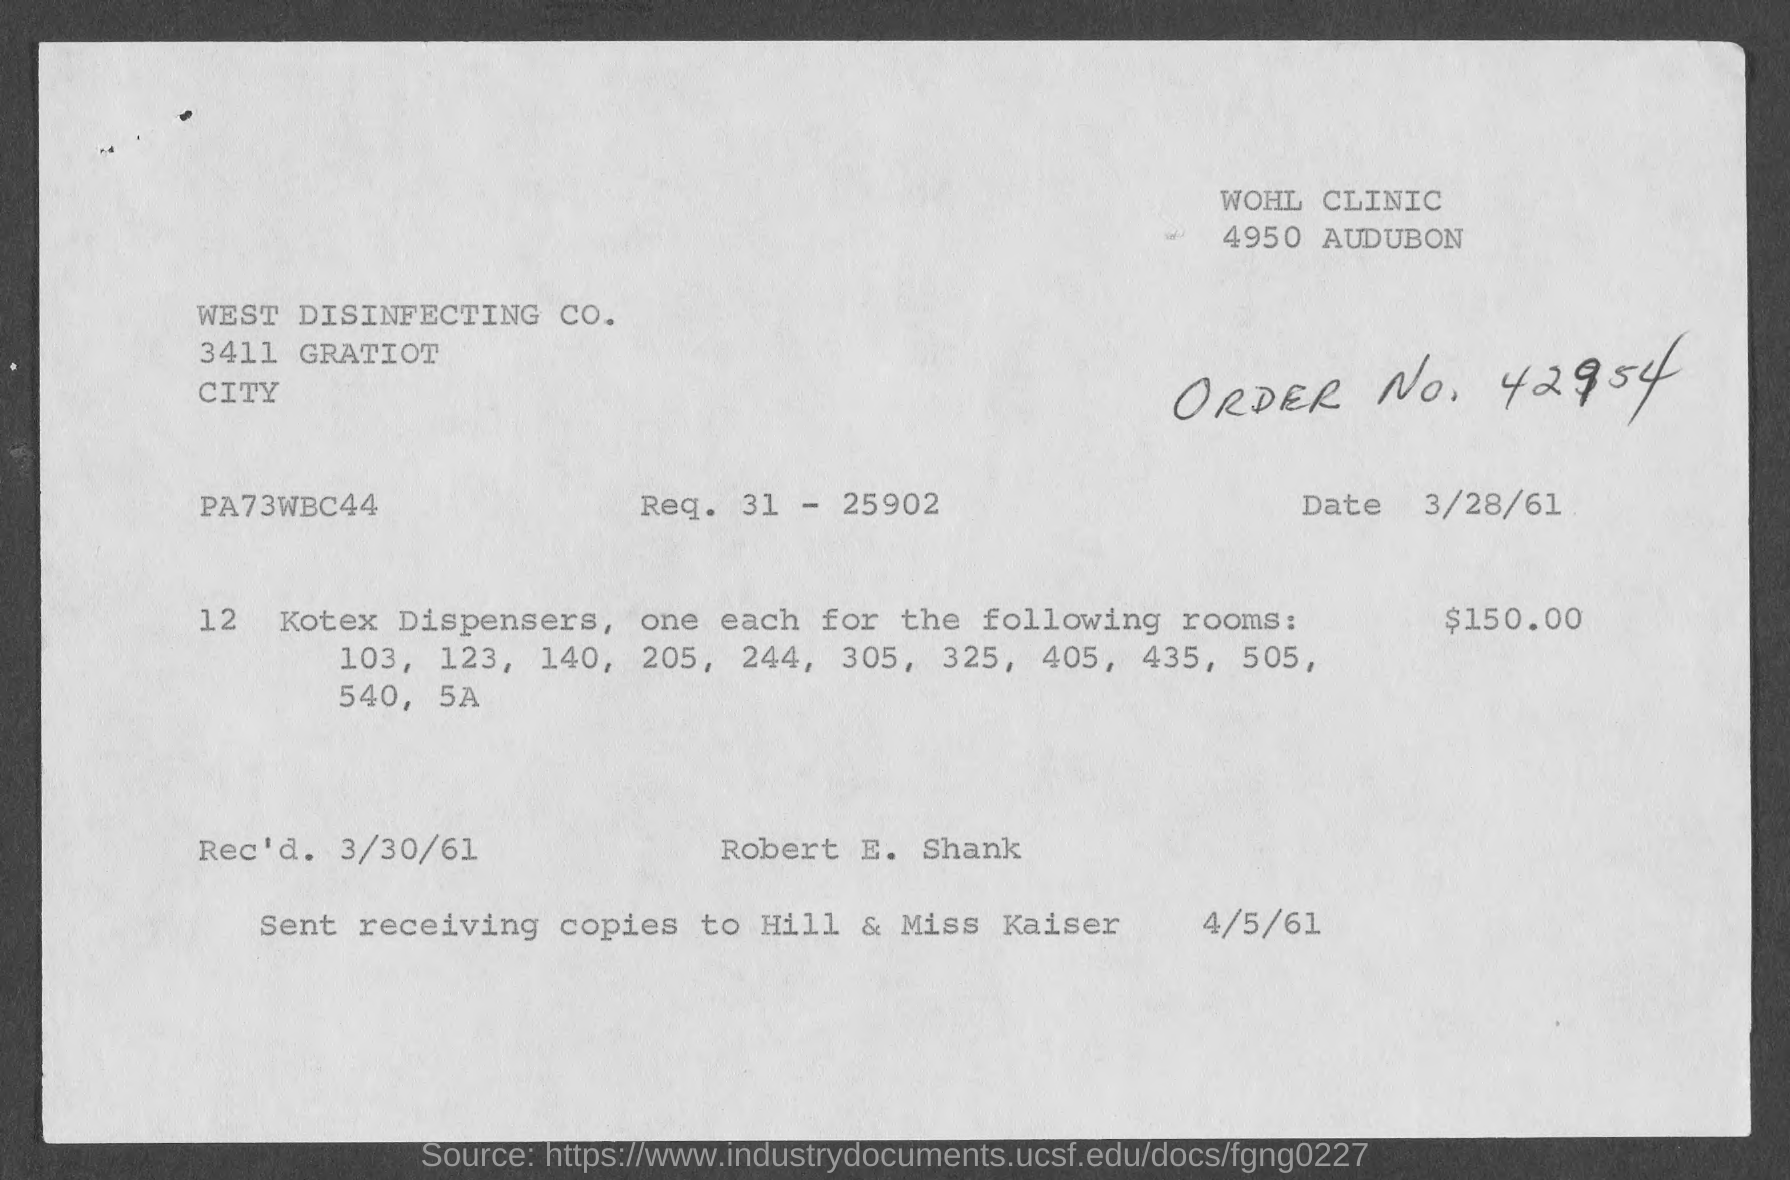Indicate a few pertinent items in this graphic. The received date of this document is March 30th, 1961. The amount for Kotex dispensers mentioned in the document is 150.00. The request number provided in the document is 31-25902. 